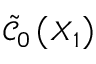<formula> <loc_0><loc_0><loc_500><loc_500>\tilde { \mathcal { C } } _ { 0 } \left ( X _ { 1 } \right )</formula> 